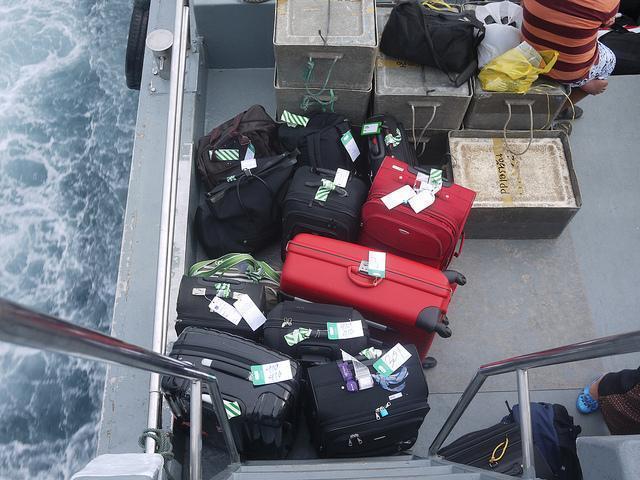How are bags identified here?
From the following set of four choices, select the accurate answer to respond to the question.
Options: Tracking device, color, tags, they aren't. Tags. 